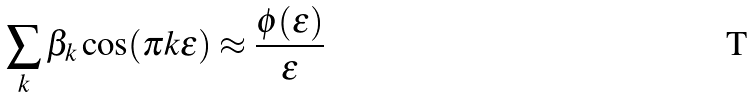Convert formula to latex. <formula><loc_0><loc_0><loc_500><loc_500>\sum _ { k } \beta _ { k } \cos ( \pi k \epsilon ) \approx \frac { \phi ( \epsilon ) } { \epsilon }</formula> 